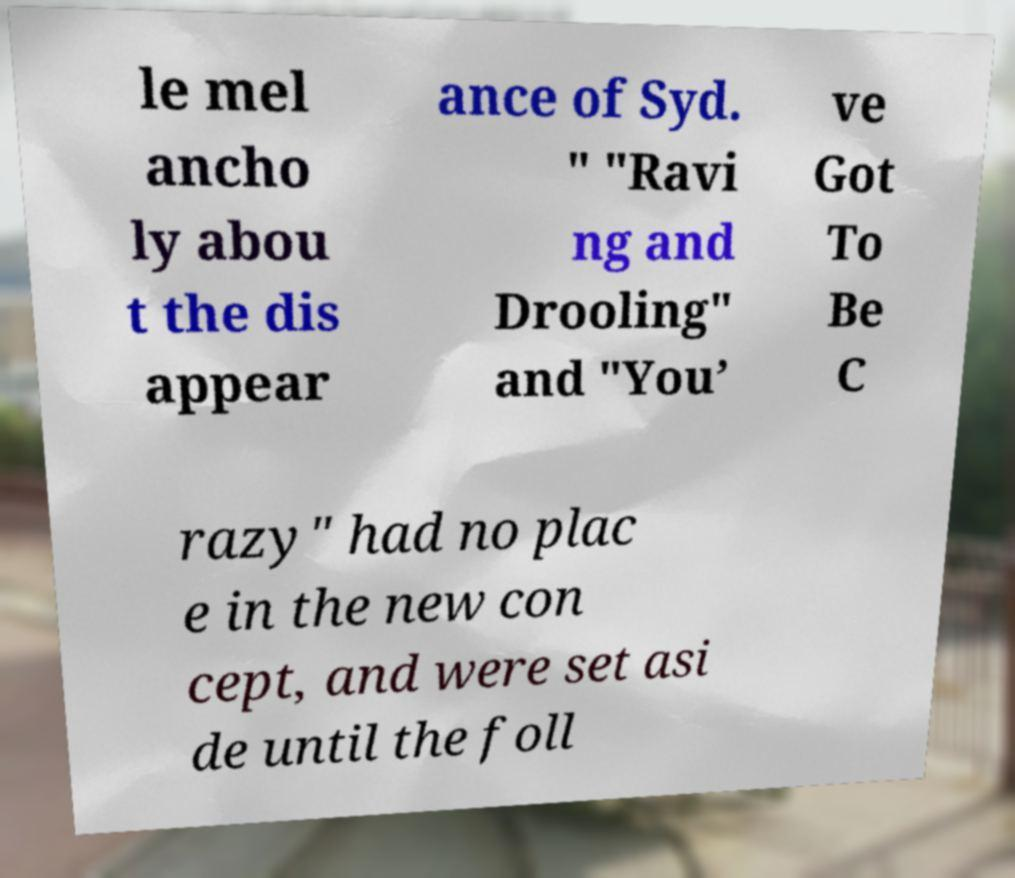Could you extract and type out the text from this image? le mel ancho ly abou t the dis appear ance of Syd. " "Ravi ng and Drooling" and "You’ ve Got To Be C razy" had no plac e in the new con cept, and were set asi de until the foll 